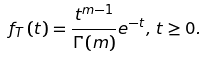<formula> <loc_0><loc_0><loc_500><loc_500>{ f _ { T } } \left ( t \right ) = \frac { { { t ^ { m - 1 } } } } { \Gamma \left ( m \right ) } { e ^ { - t } } , \, t \geq 0 .</formula> 